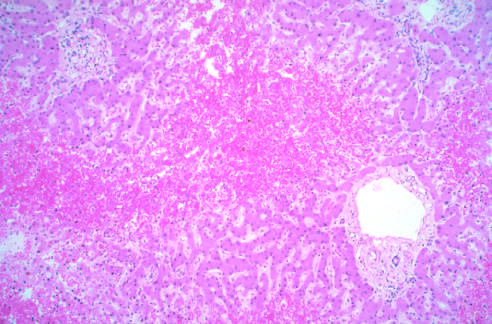what are intact?
Answer the question using a single word or phrase. Portal tracts and the periportal parenchyma 